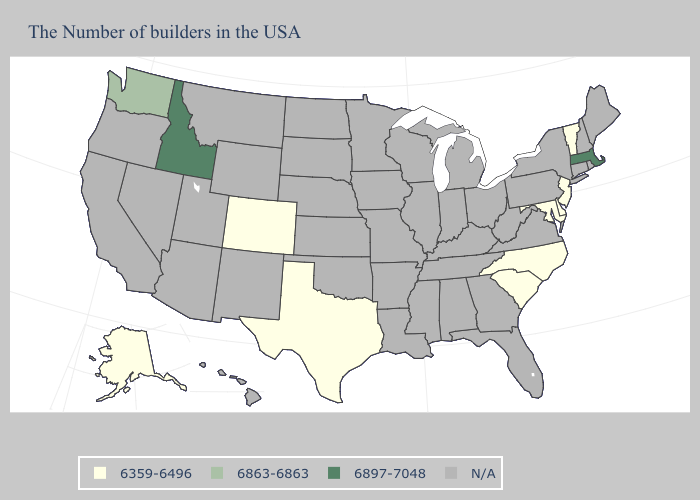What is the value of Wyoming?
Short answer required. N/A. What is the lowest value in the USA?
Write a very short answer. 6359-6496. Does the map have missing data?
Give a very brief answer. Yes. Which states hav the highest value in the Northeast?
Quick response, please. Massachusetts. Name the states that have a value in the range 6359-6496?
Write a very short answer. Vermont, New Jersey, Delaware, Maryland, North Carolina, South Carolina, Texas, Colorado, Alaska. What is the value of Indiana?
Give a very brief answer. N/A. Name the states that have a value in the range N/A?
Short answer required. Maine, Rhode Island, New Hampshire, Connecticut, New York, Pennsylvania, Virginia, West Virginia, Ohio, Florida, Georgia, Michigan, Kentucky, Indiana, Alabama, Tennessee, Wisconsin, Illinois, Mississippi, Louisiana, Missouri, Arkansas, Minnesota, Iowa, Kansas, Nebraska, Oklahoma, South Dakota, North Dakota, Wyoming, New Mexico, Utah, Montana, Arizona, Nevada, California, Oregon, Hawaii. Does Massachusetts have the highest value in the USA?
Give a very brief answer. Yes. Which states hav the highest value in the South?
Keep it brief. Delaware, Maryland, North Carolina, South Carolina, Texas. Name the states that have a value in the range N/A?
Concise answer only. Maine, Rhode Island, New Hampshire, Connecticut, New York, Pennsylvania, Virginia, West Virginia, Ohio, Florida, Georgia, Michigan, Kentucky, Indiana, Alabama, Tennessee, Wisconsin, Illinois, Mississippi, Louisiana, Missouri, Arkansas, Minnesota, Iowa, Kansas, Nebraska, Oklahoma, South Dakota, North Dakota, Wyoming, New Mexico, Utah, Montana, Arizona, Nevada, California, Oregon, Hawaii. How many symbols are there in the legend?
Answer briefly. 4. Does the first symbol in the legend represent the smallest category?
Write a very short answer. Yes. 